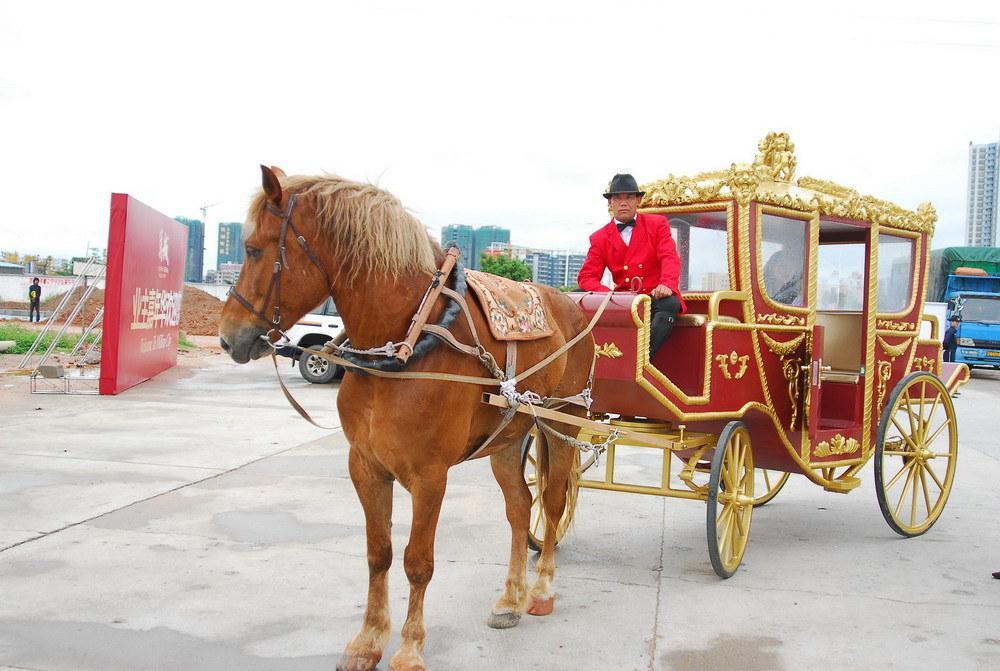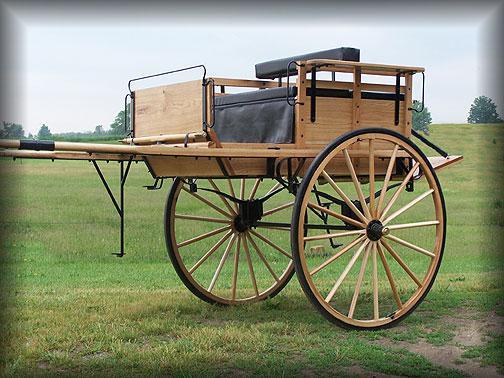The first image is the image on the left, the second image is the image on the right. For the images displayed, is the sentence "All the carriages are facing left." factually correct? Answer yes or no. Yes. The first image is the image on the left, the second image is the image on the right. Examine the images to the left and right. Is the description "Both of the carts are covered." accurate? Answer yes or no. No. 